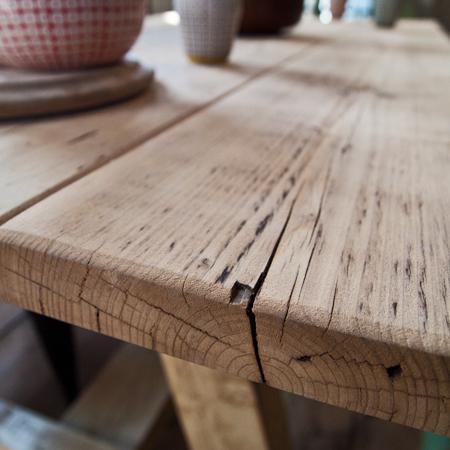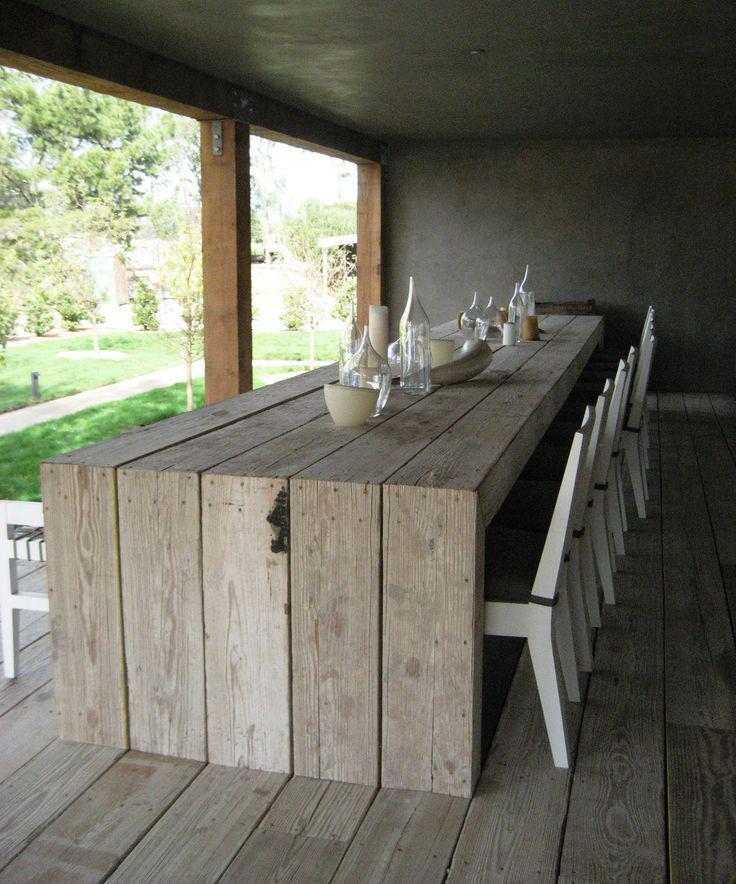The first image is the image on the left, the second image is the image on the right. For the images shown, is this caption "One table has bench seating." true? Answer yes or no. No. The first image is the image on the left, the second image is the image on the right. Considering the images on both sides, is "There is a bench left of the table in one of the images" valid? Answer yes or no. No. 